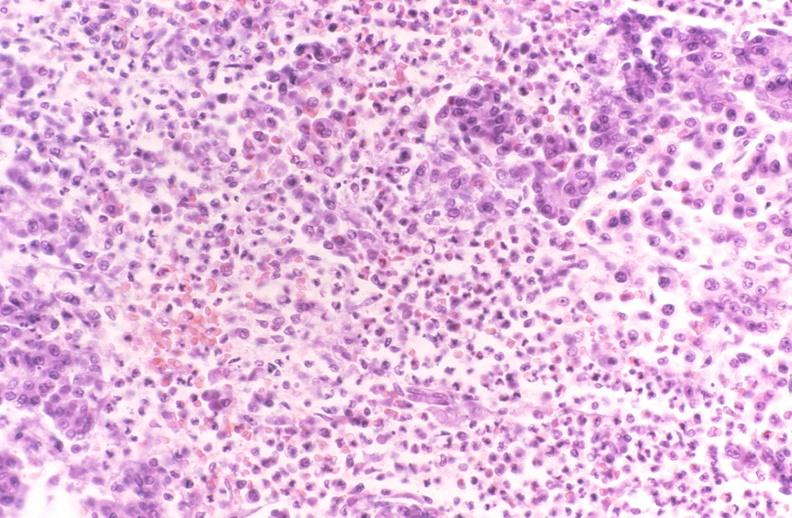where is this?
Answer the question using a single word or phrase. Pancreas 